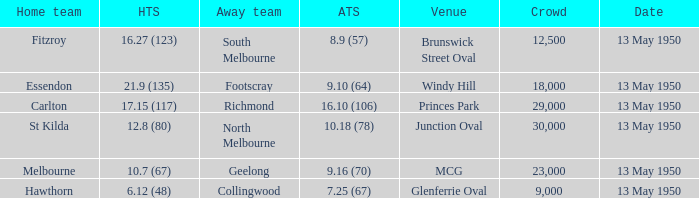Who was the away team that played Fitzroy on May 13, 1950 at Brunswick Street Oval. South Melbourne. 